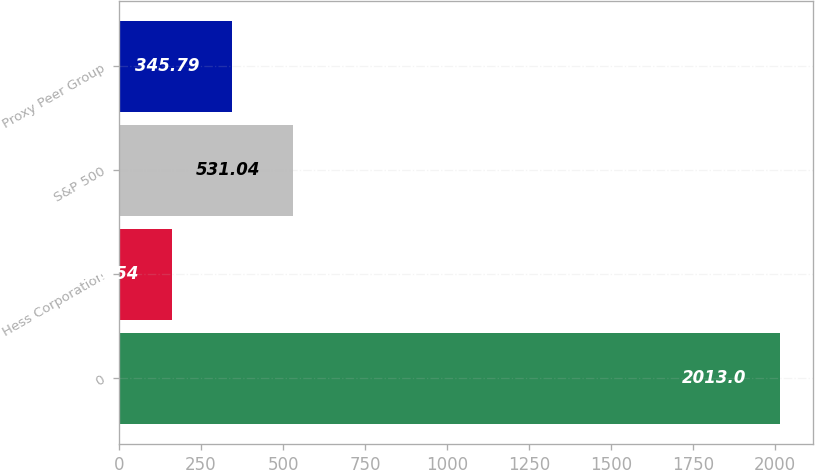Convert chart. <chart><loc_0><loc_0><loc_500><loc_500><bar_chart><fcel>0<fcel>Hess Corporation<fcel>S&P 500<fcel>Proxy Peer Group<nl><fcel>2013<fcel>160.54<fcel>531.04<fcel>345.79<nl></chart> 